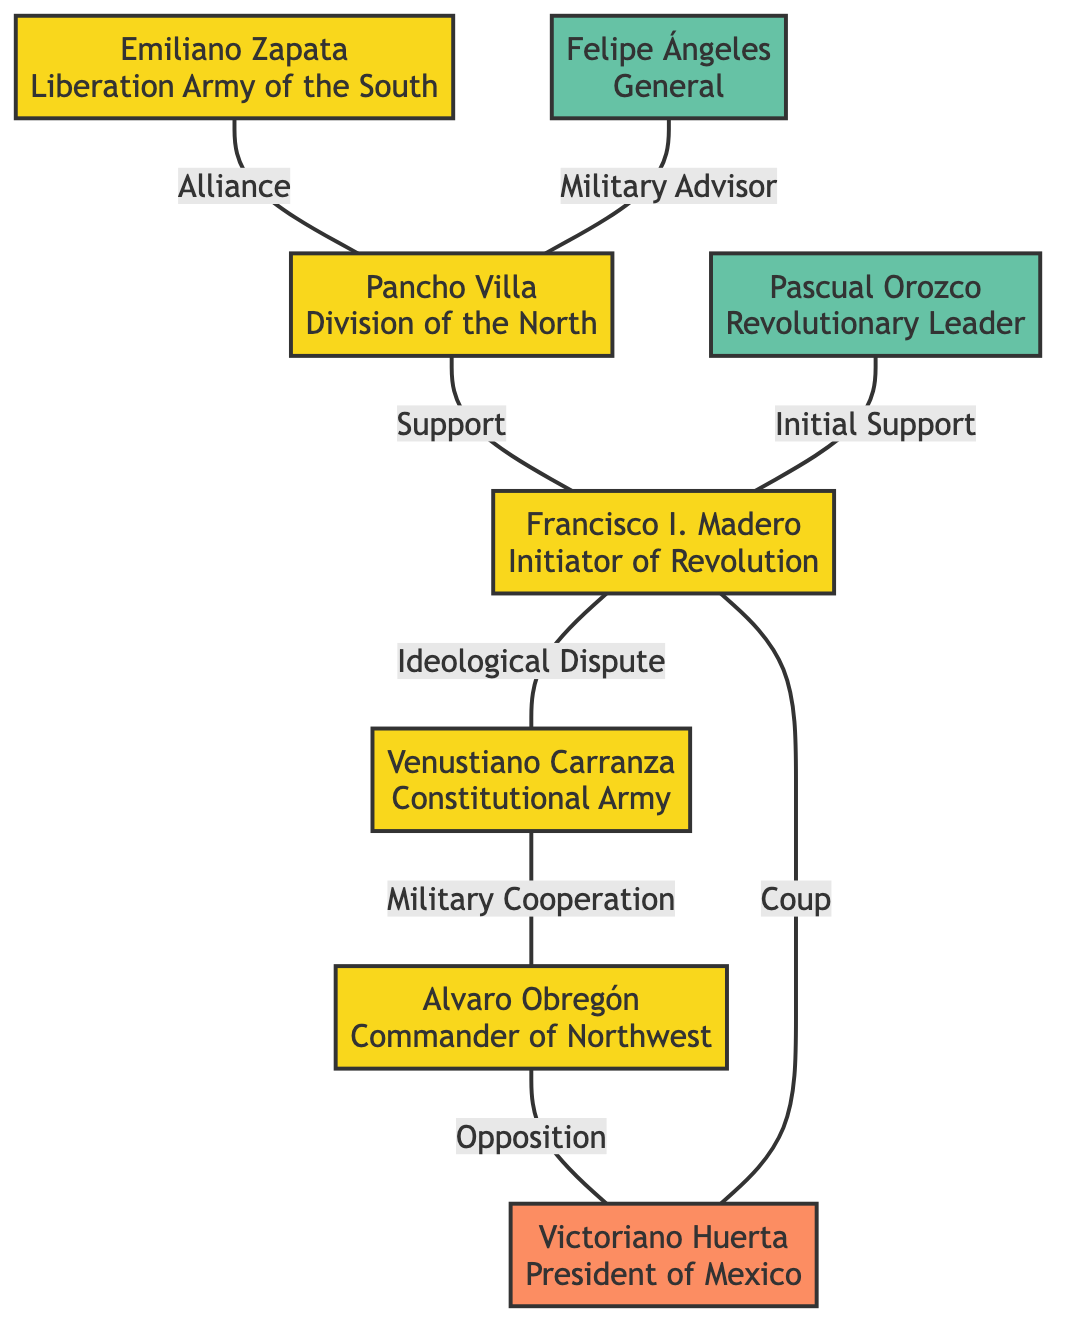What are the two main alliances depicted in the network? The diagram shows an alliance between Emiliano Zapata and Pancho Villa, and also a military cooperation between Venustiano Carranza and Alvaro Obregón.
Answer: Emiliano Zapata and Pancho Villa; Venustiano Carranza and Alvaro Obregón Who is the leader of the Division of the North? The diagram identifies Pancho Villa as the leader of the Division of the North, as labeled in his node.
Answer: Pancho Villa What type of dispute exists between Francisco I. Madero and Venustiano Carranza? The diagram notes that there is an ideological dispute between Francisco I. Madero and Venustiano Carranza, as indicated by the label on their connecting edge.
Answer: Ideological Dispute How many advisors are mentioned in the diagram? The diagram lists two advisors: Pascual Orozco and Felipe Ángeles, so there are a total of two advisors present in the diagram.
Answer: 2 What does the arrow between Pancho Villa and Francisco I. Madero indicate? The arrow signifies that Pancho Villa provided support to Francisco I. Madero, which is explicitly written on the edge connecting these two figures.
Answer: Support What is the relationship depicted between Alvaro Obregón and Victoriano Huerta? The diagram indicates that Alvaro Obregón has opposition to Victoriano Huerta, as shown by the connecting edge labeled as opposition in the diagram.
Answer: Opposition Who provided initial support to Francisco I. Madero? The diagram specifically highlights that Pascual Orozco provided initial support to Francisco I. Madero, which is stated on their connecting edge.
Answer: Pascual Orozco What military role does Felipe Ángeles have in the diagram? Felipe Ángeles is identified as a military advisor to Pancho Villa, reflecting his role in the network of alliances and support among the leaders.
Answer: Military Advisor What event does the arrow from Victoriano Huerta to Francisco I. Madero represent? The diagram marks a coup by Victoriano Huerta against Francisco I. Madero, as denoted by the label on their connecting edge.
Answer: Coup 